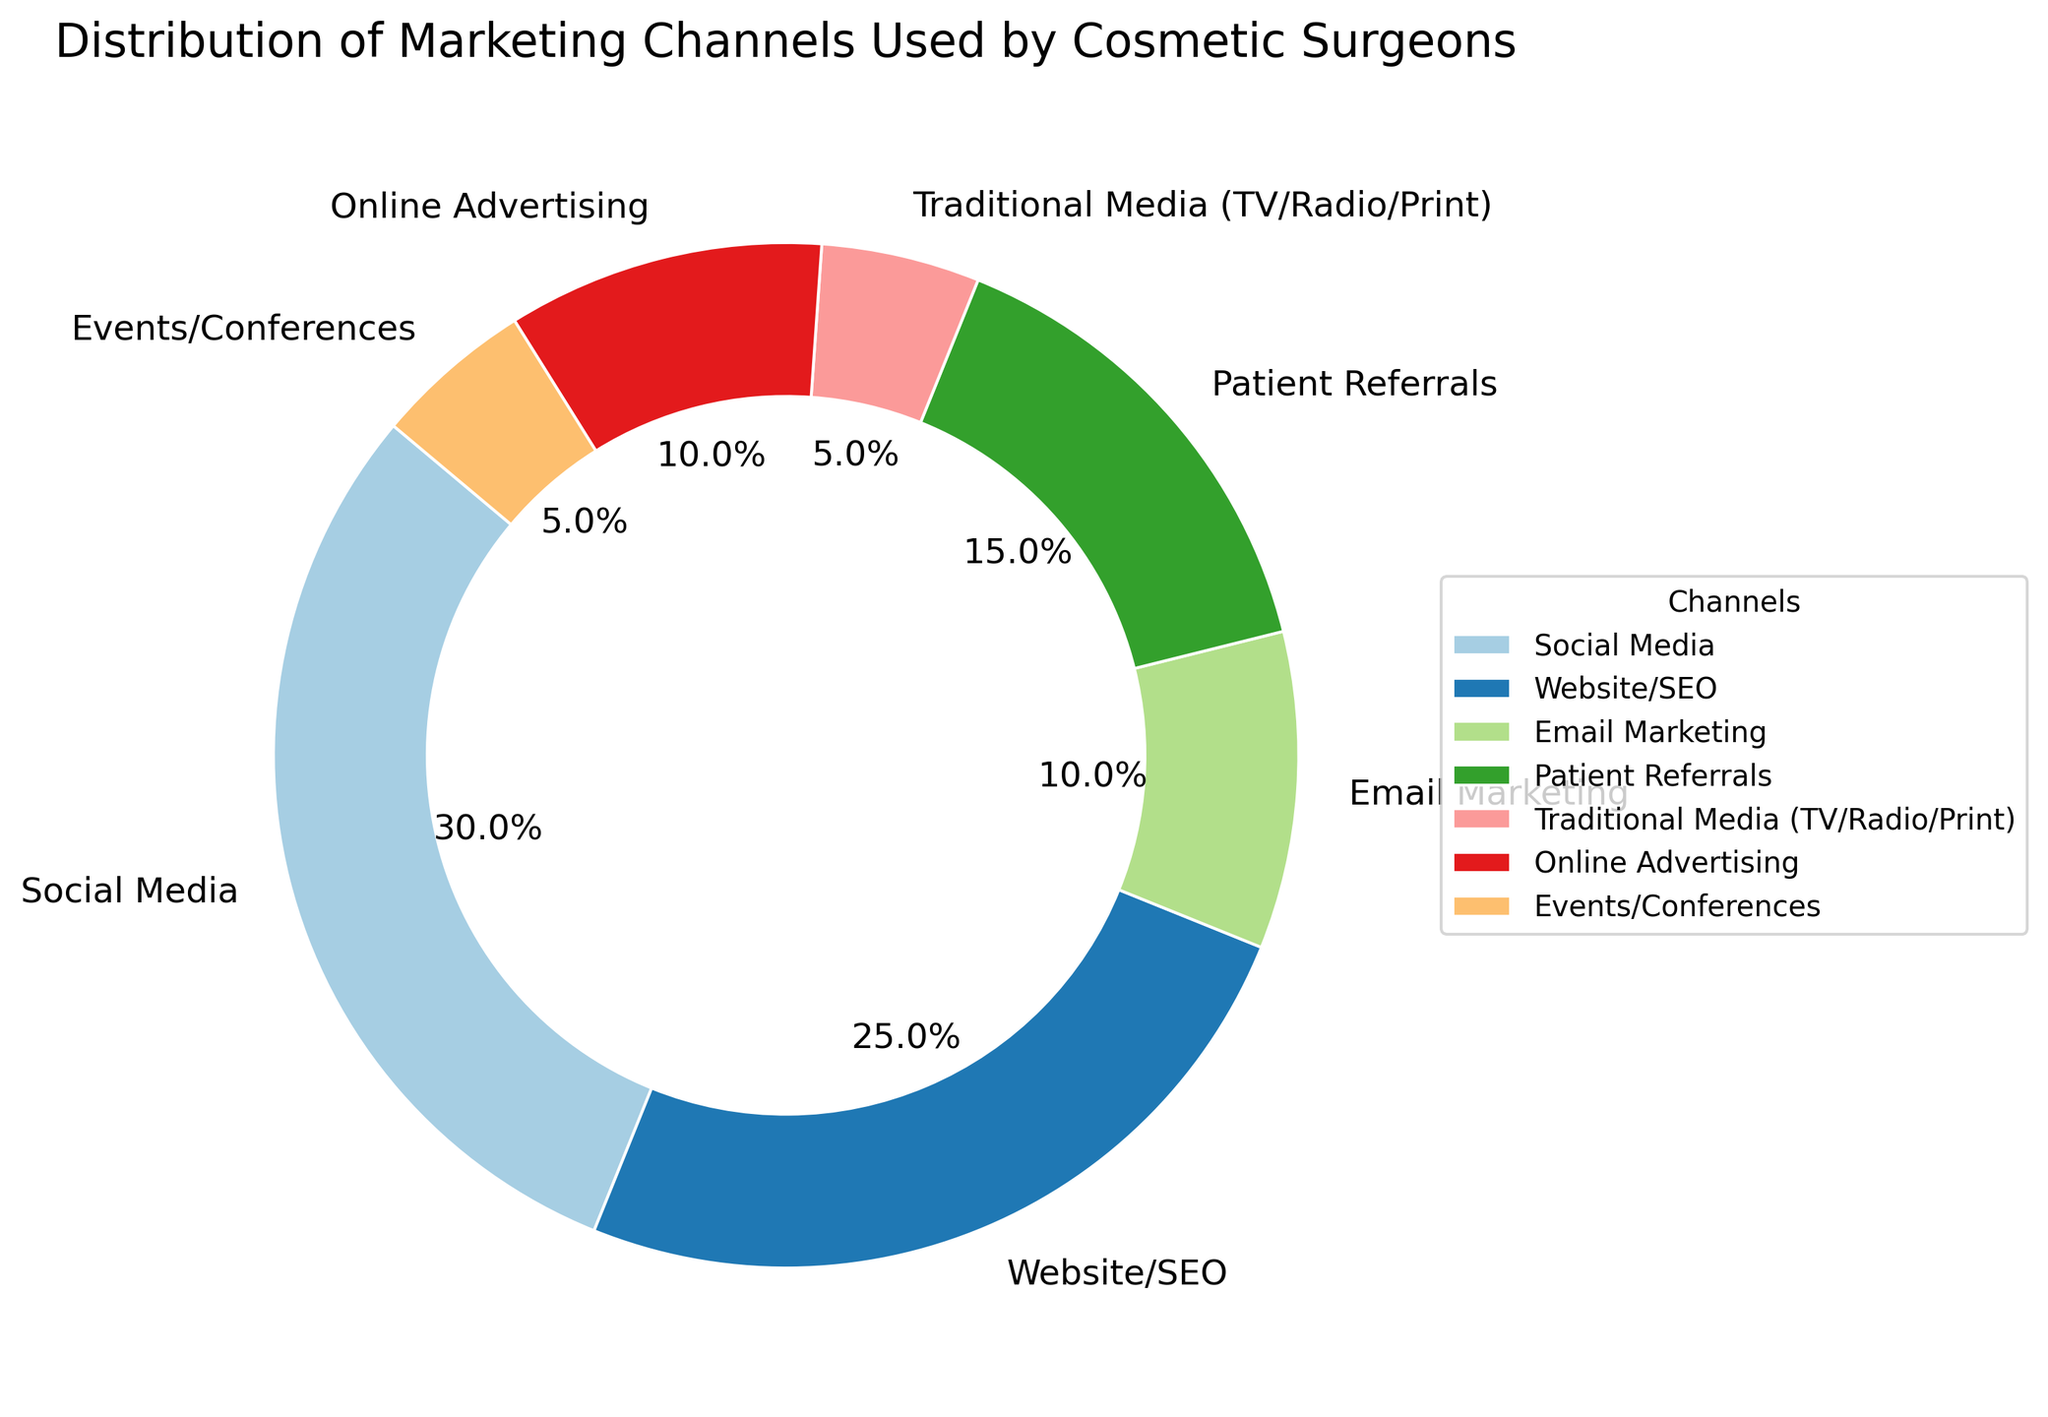What percentage of cosmetic surgeons use Social Media for marketing? The pie chart shows that the Social Media segment occupies 30% of the total distribution.
Answer: 30% Which two channels have the same percentage and what is that percentage? Looking at the pie chart, Online Advertising and Email Marketing both have the same segment size. The percentage for both is 10%.
Answer: Online Advertising and Email Marketing, 10% What is the combined percentage of Patient Referrals and Traditional Media? The percentage for Patient Referrals is 15% and for Traditional Media is 5%. Adding these together gives 15% + 5% = 20%.
Answer: 20% Which marketing channel has the smallest percentage, and how much is it? The smallest portion of the pie chart is occupied by Traditional Media and Events/Conferences. Each has a percentage of 5%.
Answer: Traditional Media and Events/Conferences, 5% Compare the usage of Social Media to that of Website/SEO. Which one is higher and by how much? The Social Media segment is 30% and the Website/SEO segment is 25%. The difference between them is 30% - 25% = 5%.
Answer: Social Media by 5% What is the total percentage for digital marketing channels (Social Media, Website/SEO, Email Marketing, Online Advertising)? Adding the percentages for Social Media (30%), Website/SEO (25%), Email Marketing (10%), and Online Advertising (10%) gives 30% + 25% + 10% + 10% = 75%.
Answer: 75% How does the percentage of Patient Referrals compare to that of Online Advertising? The percentage for Patient Referrals is 15%, while Online Advertising accounts for 10%. Therefore, Patient Referrals is higher by 5%.
Answer: Patient Referrals is higher by 5% If you sum up the two least used marketing channels, what percentage do you get? The two least used channels are Traditional Media and Events/Conferences with 5% each. Summing these gives 5% + 5% = 10%.
Answer: 10% What is the difference between the percentages of the most used channel and the least used channel? The most used channel, Social Media, has 30% and the least used channels, Traditional Media and Events/Conferences, have 5% each. The difference is 30% - 5% = 25%.
Answer: 25% Which marketing channel is used more, Patient Referrals or Events/Conferences? By how much? Patient Referrals have a percentage of 15% and Events/Conferences have 5%. Therefore, Patient Referrals is used 15% - 5% = 10% more than Events/Conferences.
Answer: Patient Referrals by 10% 